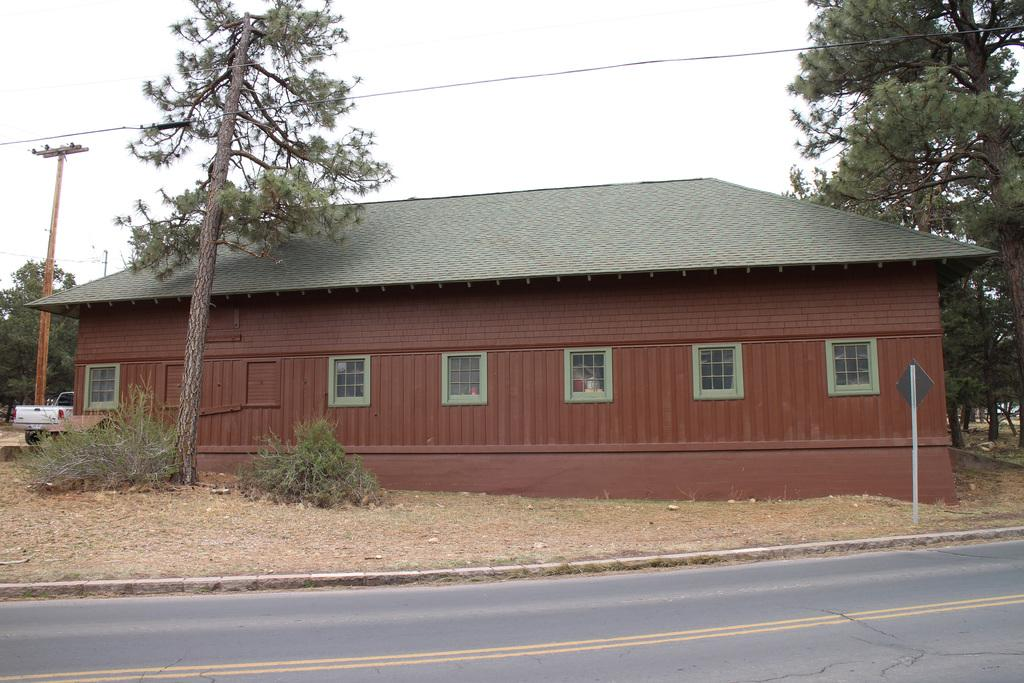What type of structure is present in the image? There is a house in the image. What feature of the house is mentioned in the facts? The house has windows. What else can be seen in the image besides the house? There are trees, a vehicle, and a road in the image. What type of cherry is being used to fix the vehicle in the image? There is no cherry present in the image, nor is there any indication that a vehicle is being fixed. 